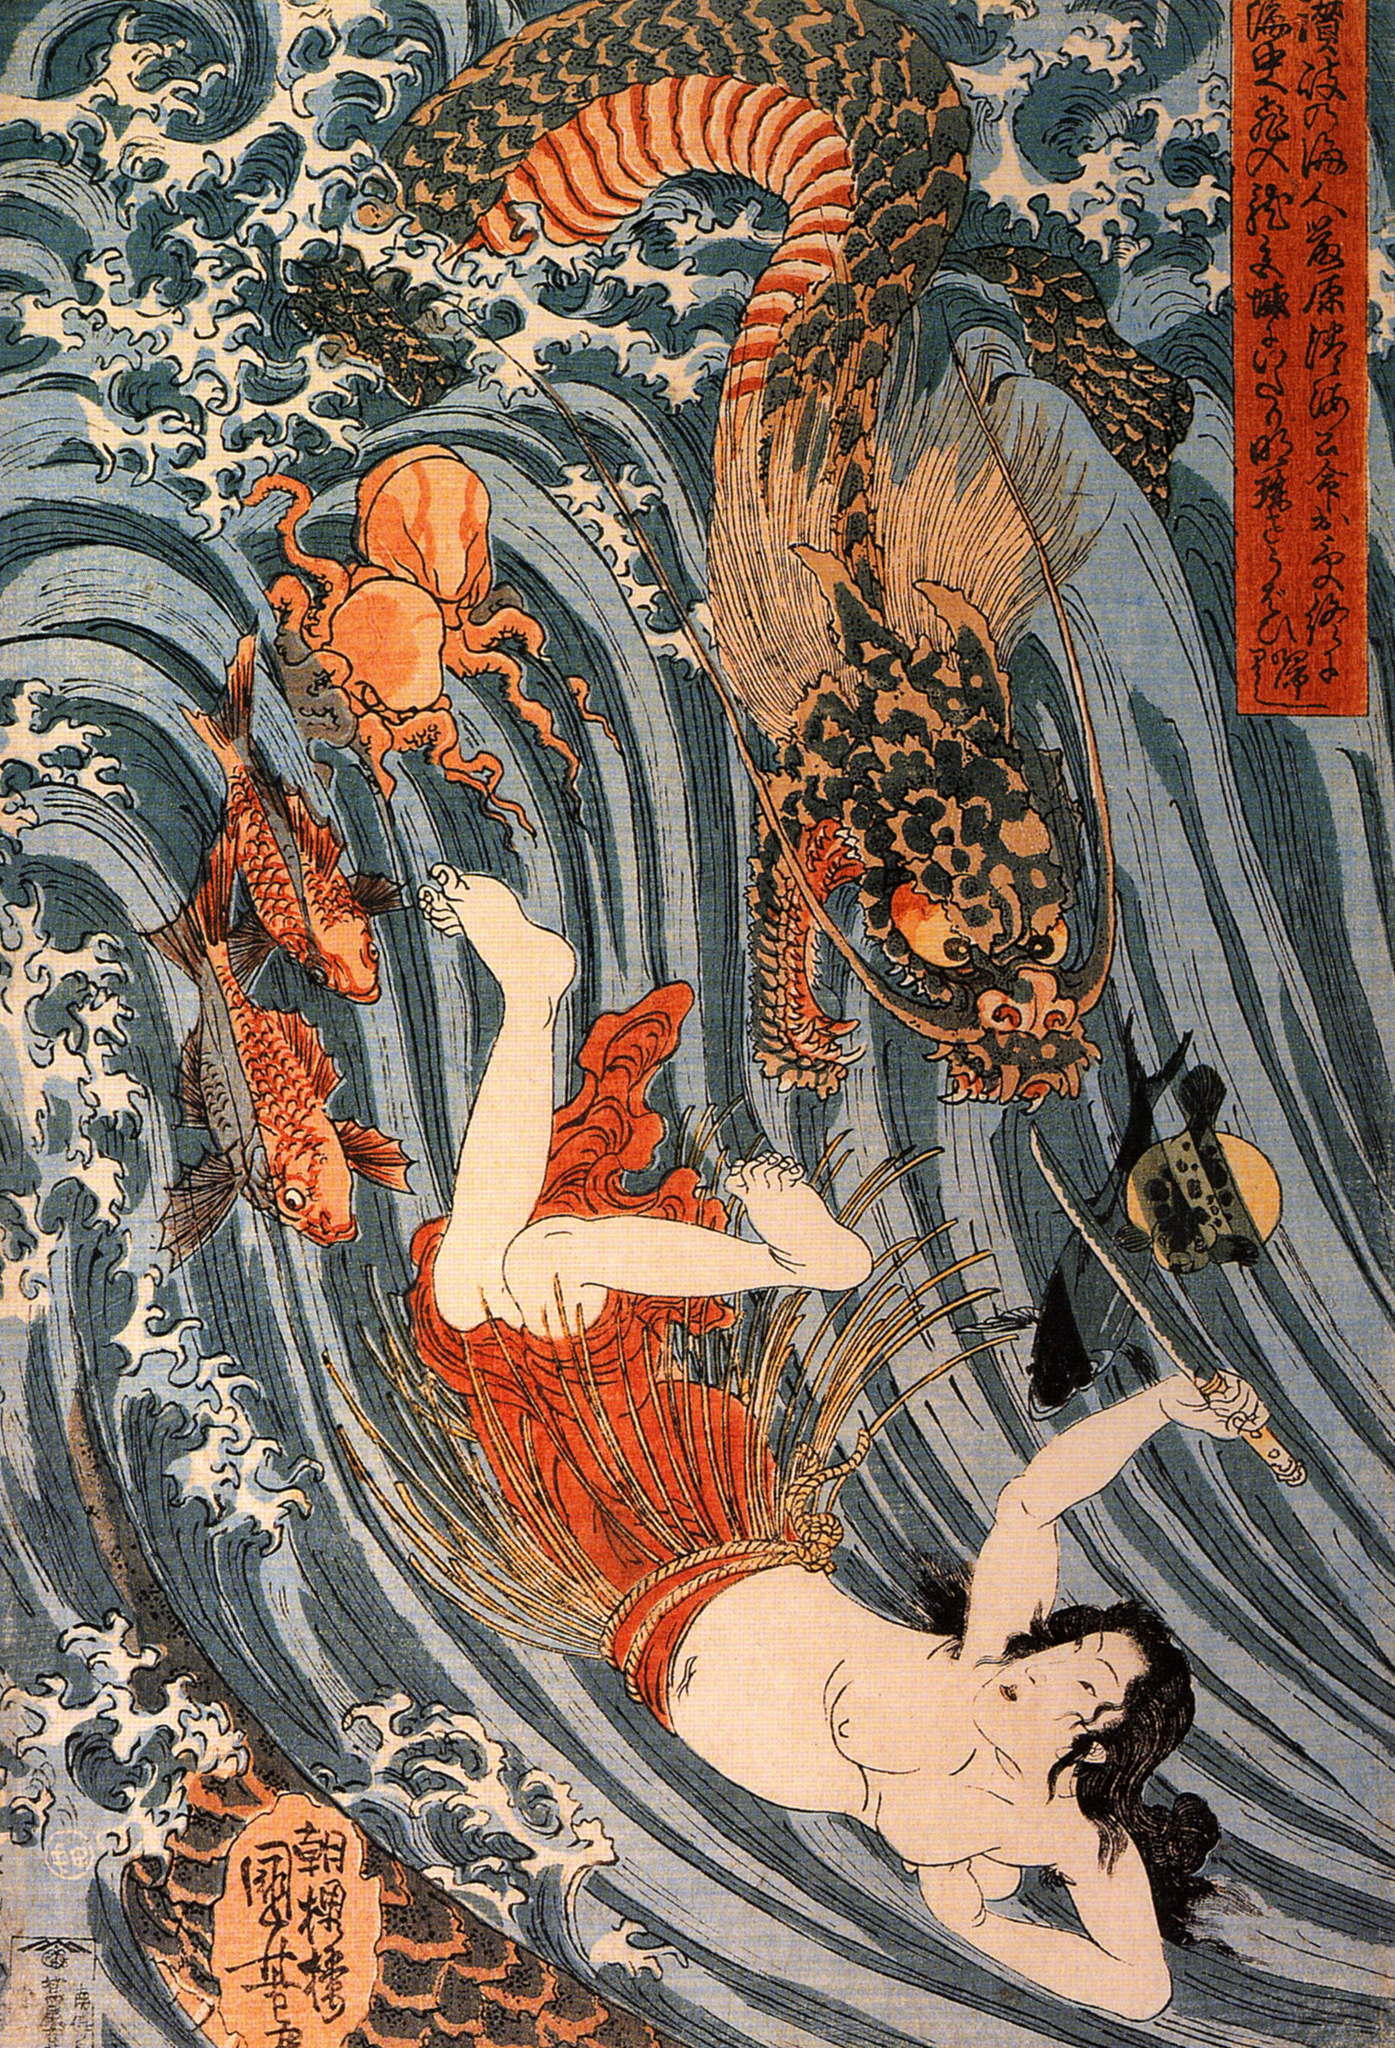What does the woman's attire and pose tell us about her character? The woman’s attire, consisting of a red and white garment, and her active pose with a fan, signifies grace and resilience. Historically, these colors are often associated with auspiciousness and vitality in Japanese culture. Her interaction with the dragon without visible fear could suggest she holds a special status, possibly divine or spiritual, letting her bridge the human and mythical realms. 